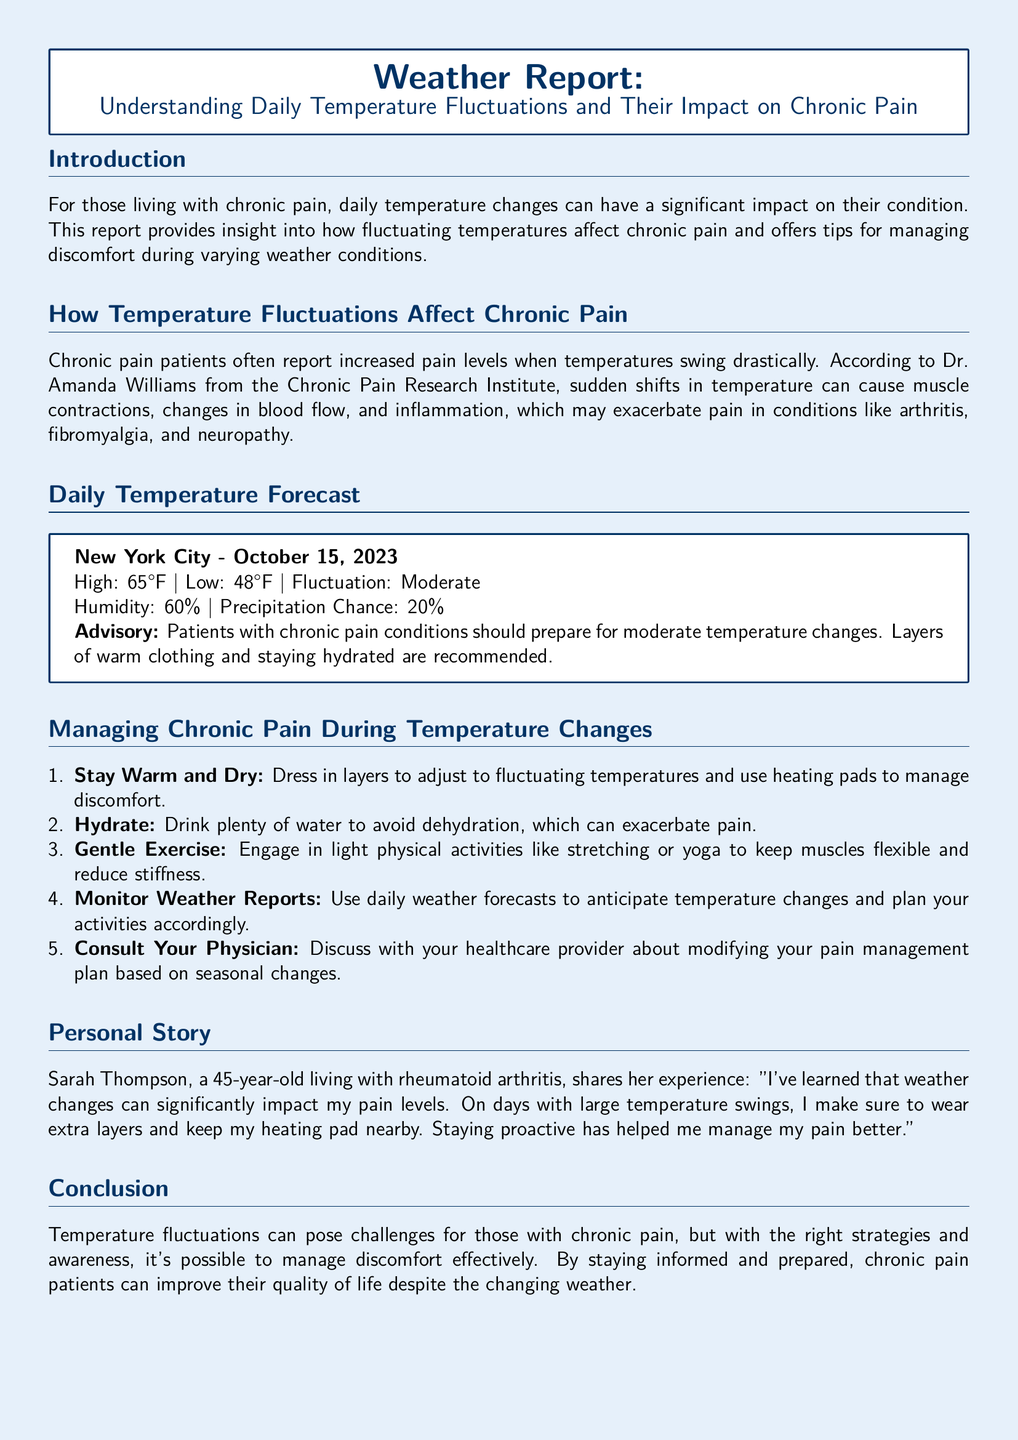What is the high temperature forecasted for New York City on October 15, 2023? The high temperature for New York City on October 15, 2023, is specified in the daily temperature forecast section.
Answer: 65°F What is the low temperature forecasted for New York City on October 15, 2023? The low temperature for New York City on October 15, 2023, is also included in the daily temperature forecast section.
Answer: 48°F What humidity percentage is expected in New York City on October 15, 2023? The humidity percentage is mentioned in the daily temperature forecast section.
Answer: 60% What is the precipitation chance for New York City on October 15, 2023? The precipitation chance is provided in the daily temperature forecast section.
Answer: 20% What should chronic pain patients wear to prepare for temperature changes? This advice is given in the managing chronic pain section, highlighting the importance of appropriate clothing.
Answer: Layers of warm clothing How can staying hydrated help chronic pain patients? The document explains hydration's benefits in managing chronic pain during temperature changes.
Answer: Avoid dehydration What type of exercise is recommended for chronic pain management? The suggested exercise type is noted in the managing chronic pain section.
Answer: Gentle exercise Who provided insights on temperature fluctuations and chronic pain? This detail can be found in the section discussing how temperature fluctuations affect chronic pain.
Answer: Dr. Amanda Williams What condition does Sarah Thompson have? Sarah Thompson's condition is specified in the personal story section.
Answer: Rheumatoid arthritis 